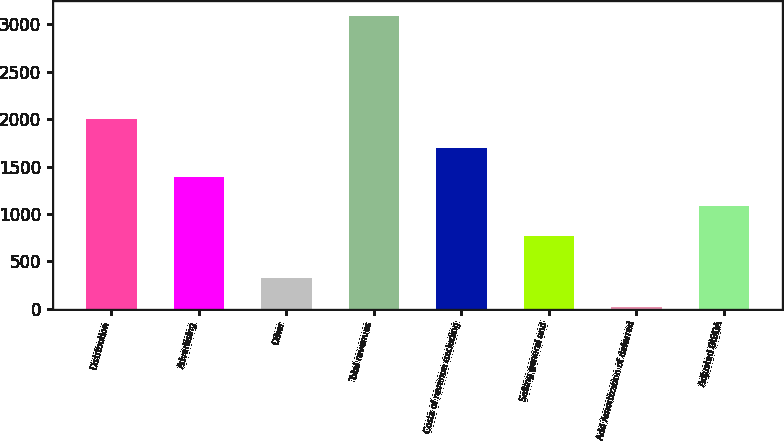Convert chart to OTSL. <chart><loc_0><loc_0><loc_500><loc_500><bar_chart><fcel>Distribution<fcel>Advertising<fcel>Other<fcel>Total revenues<fcel>Costs of revenue excluding<fcel>Selling general and<fcel>Add Amortization of deferred<fcel>Adjusted OIBDA<nl><fcel>2002.4<fcel>1387.2<fcel>323.6<fcel>3092<fcel>1694.8<fcel>772<fcel>16<fcel>1079.6<nl></chart> 